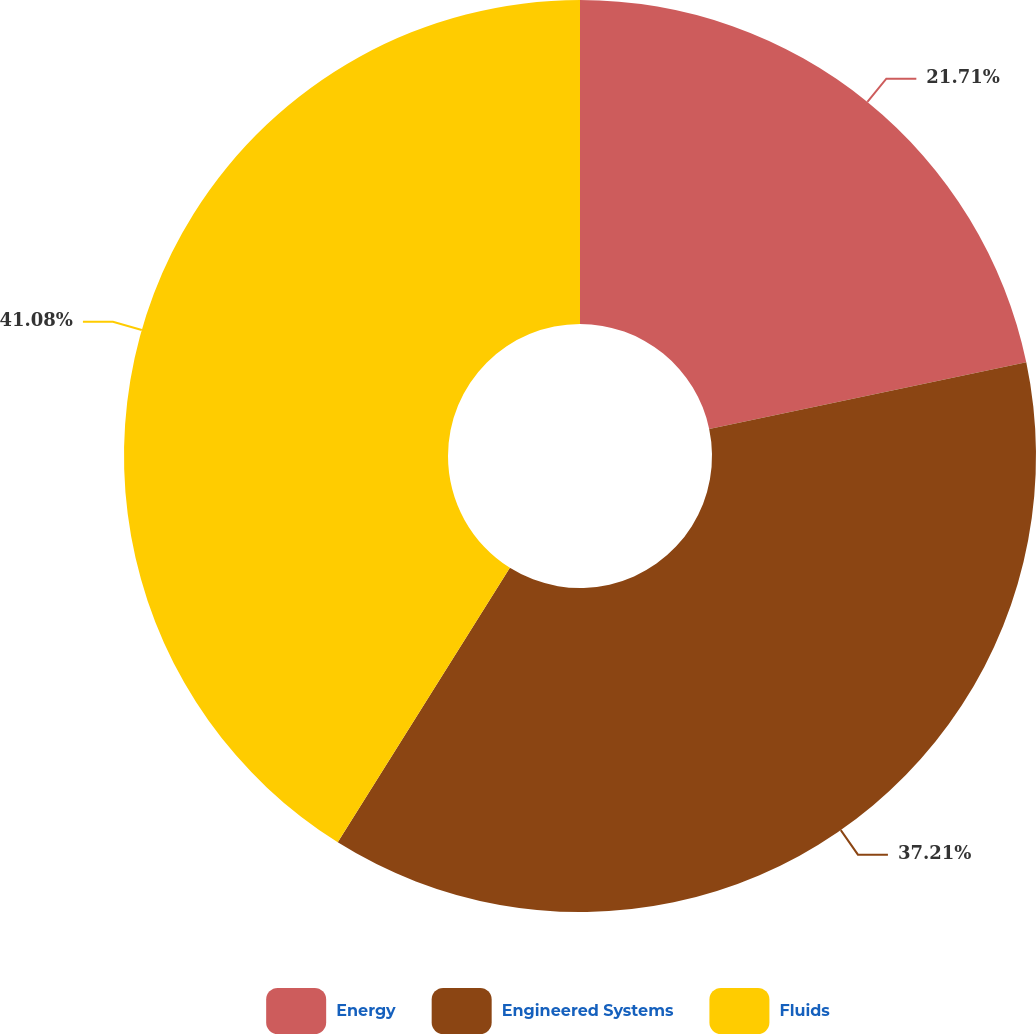Convert chart to OTSL. <chart><loc_0><loc_0><loc_500><loc_500><pie_chart><fcel>Energy<fcel>Engineered Systems<fcel>Fluids<nl><fcel>21.71%<fcel>37.21%<fcel>41.09%<nl></chart> 